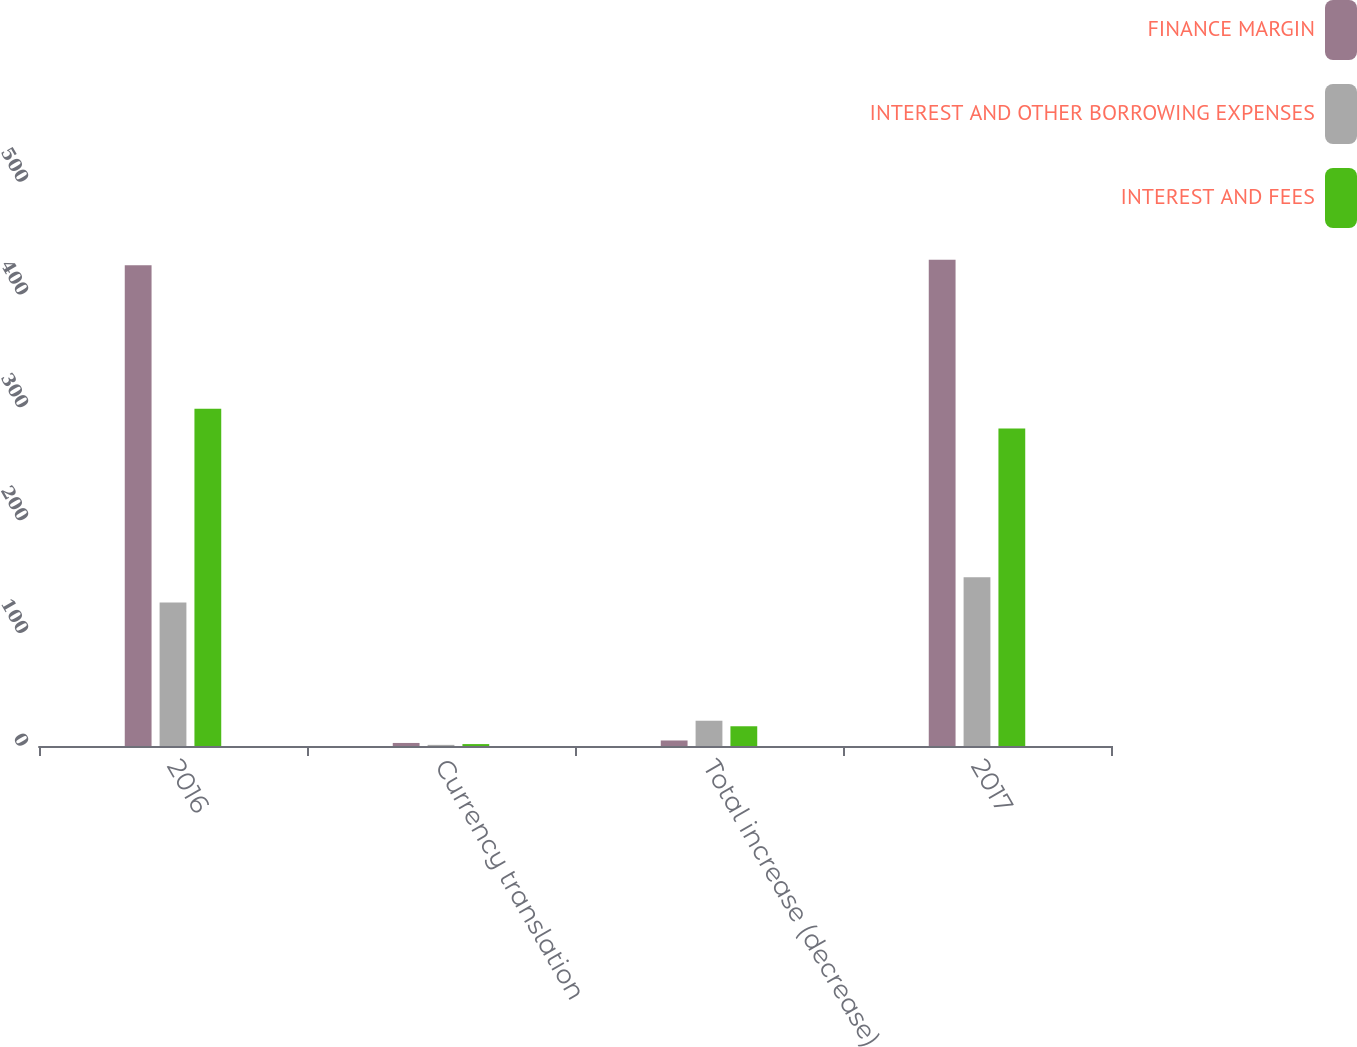Convert chart to OTSL. <chart><loc_0><loc_0><loc_500><loc_500><stacked_bar_chart><ecel><fcel>2016<fcel>Currency translation<fcel>Total increase (decrease)<fcel>2017<nl><fcel>FINANCE MARGIN<fcel>426.2<fcel>2.7<fcel>4.9<fcel>431.1<nl><fcel>INTEREST AND OTHER BORROWING EXPENSES<fcel>127.2<fcel>1<fcel>22.4<fcel>149.6<nl><fcel>INTEREST AND FEES<fcel>299<fcel>1.7<fcel>17.5<fcel>281.5<nl></chart> 